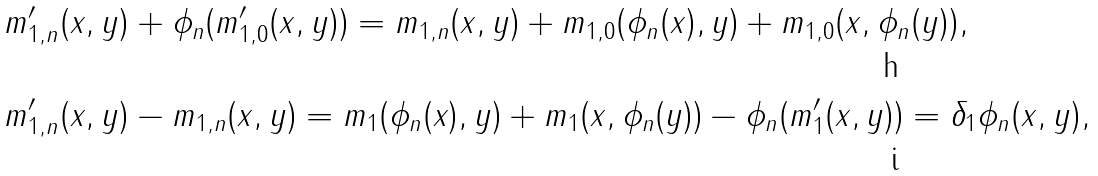<formula> <loc_0><loc_0><loc_500><loc_500>& m \rq _ { 1 , n } ( x , y ) + \phi _ { n } ( m \rq _ { 1 , 0 } ( x , y ) ) = m _ { 1 , n } ( x , y ) + m _ { 1 , 0 } ( \phi _ { n } ( x ) , y ) + m _ { 1 , 0 } ( x , \phi _ { n } ( y ) ) , \\ & m \rq _ { 1 , n } ( x , y ) - m _ { 1 , n } ( x , y ) = m _ { 1 } ( \phi _ { n } ( x ) , y ) + m _ { 1 } ( x , \phi _ { n } ( y ) ) - \phi _ { n } ( m \rq _ { 1 } ( x , y ) ) = \delta _ { 1 } \phi _ { n } ( x , y ) ,</formula> 